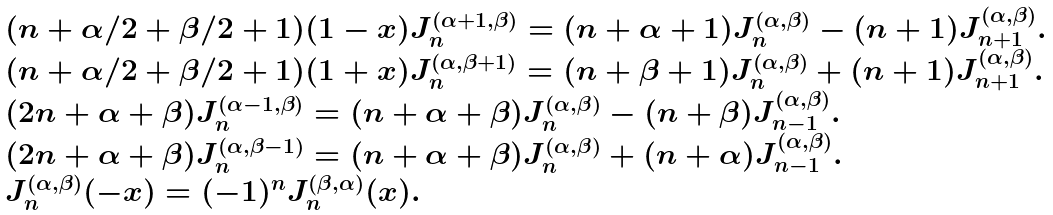<formula> <loc_0><loc_0><loc_500><loc_500>\begin{array} { l } ( n + \alpha / 2 + \beta / 2 + 1 ) ( 1 - x ) J _ { n } ^ { ( \alpha + 1 , \beta ) } = ( n + \alpha + 1 ) J _ { n } ^ { ( \alpha , \beta ) } - ( n + 1 ) J _ { n + 1 } ^ { ( \alpha , \beta ) } . \\ ( n + \alpha / 2 + \beta / 2 + 1 ) ( 1 + x ) J _ { n } ^ { ( \alpha , \beta + 1 ) } = ( n + \beta + 1 ) J _ { n } ^ { ( \alpha , \beta ) } + ( n + 1 ) J _ { n + 1 } ^ { ( \alpha , \beta ) } . \\ ( 2 n + \alpha + \beta ) J _ { n } ^ { ( \alpha - 1 , \beta ) } = ( n + \alpha + \beta ) J _ { n } ^ { ( \alpha , \beta ) } - ( n + \beta ) J _ { n - 1 } ^ { ( \alpha , \beta ) } . \\ ( 2 n + \alpha + \beta ) J _ { n } ^ { ( \alpha , \beta - 1 ) } = ( n + \alpha + \beta ) J _ { n } ^ { ( \alpha , \beta ) } + ( n + \alpha ) J _ { n - 1 } ^ { ( \alpha , \beta ) } . \\ J _ { n } ^ { ( \alpha , \beta ) } ( - x ) = ( - 1 ) ^ { n } J _ { n } ^ { ( \beta , \alpha ) } ( x ) . \end{array}</formula> 